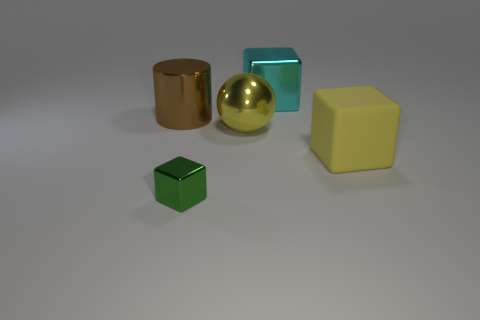What is the color of the block in front of the large yellow rubber cube?
Make the answer very short. Green. Is the number of big metal spheres that are left of the big shiny ball greater than the number of cyan objects in front of the cyan thing?
Provide a short and direct response. No. What size is the cube that is left of the shiny thing behind the big metal object that is on the left side of the small green metallic block?
Your answer should be very brief. Small. Are there any large metallic objects of the same color as the big sphere?
Offer a very short reply. No. What number of shiny cylinders are there?
Ensure brevity in your answer.  1. What is the material of the large yellow object in front of the large yellow object that is to the left of the block behind the big brown metal thing?
Provide a succinct answer. Rubber. Are there any large cylinders made of the same material as the sphere?
Give a very brief answer. Yes. Do the cyan cube and the large brown cylinder have the same material?
Offer a very short reply. Yes. What number of cylinders are big yellow metal objects or large cyan shiny things?
Ensure brevity in your answer.  0. What is the color of the sphere that is made of the same material as the green object?
Keep it short and to the point. Yellow. 